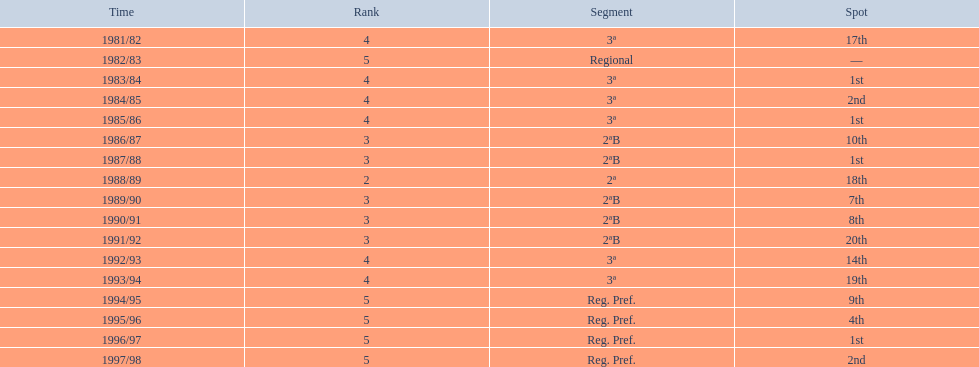Which years did the team have a season? 1981/82, 1982/83, 1983/84, 1984/85, 1985/86, 1986/87, 1987/88, 1988/89, 1989/90, 1990/91, 1991/92, 1992/93, 1993/94, 1994/95, 1995/96, 1996/97, 1997/98. Which of those years did the team place outside the top 10? 1981/82, 1988/89, 1991/92, 1992/93, 1993/94. Which of the years in which the team placed outside the top 10 did they have their worst performance? 1991/92. 